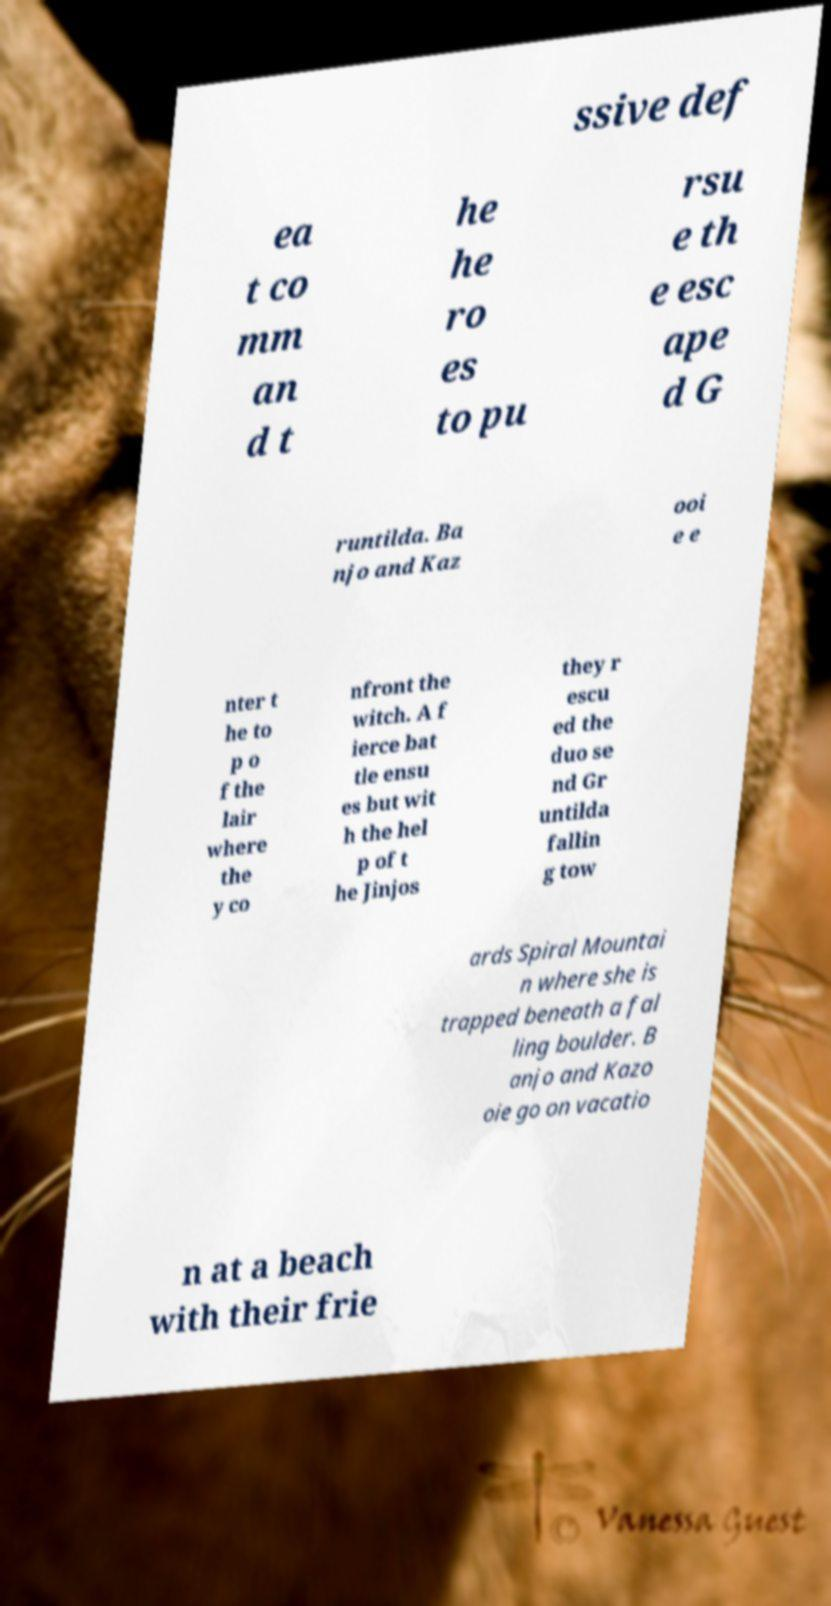Please identify and transcribe the text found in this image. ssive def ea t co mm an d t he he ro es to pu rsu e th e esc ape d G runtilda. Ba njo and Kaz ooi e e nter t he to p o f the lair where the y co nfront the witch. A f ierce bat tle ensu es but wit h the hel p of t he Jinjos they r escu ed the duo se nd Gr untilda fallin g tow ards Spiral Mountai n where she is trapped beneath a fal ling boulder. B anjo and Kazo oie go on vacatio n at a beach with their frie 